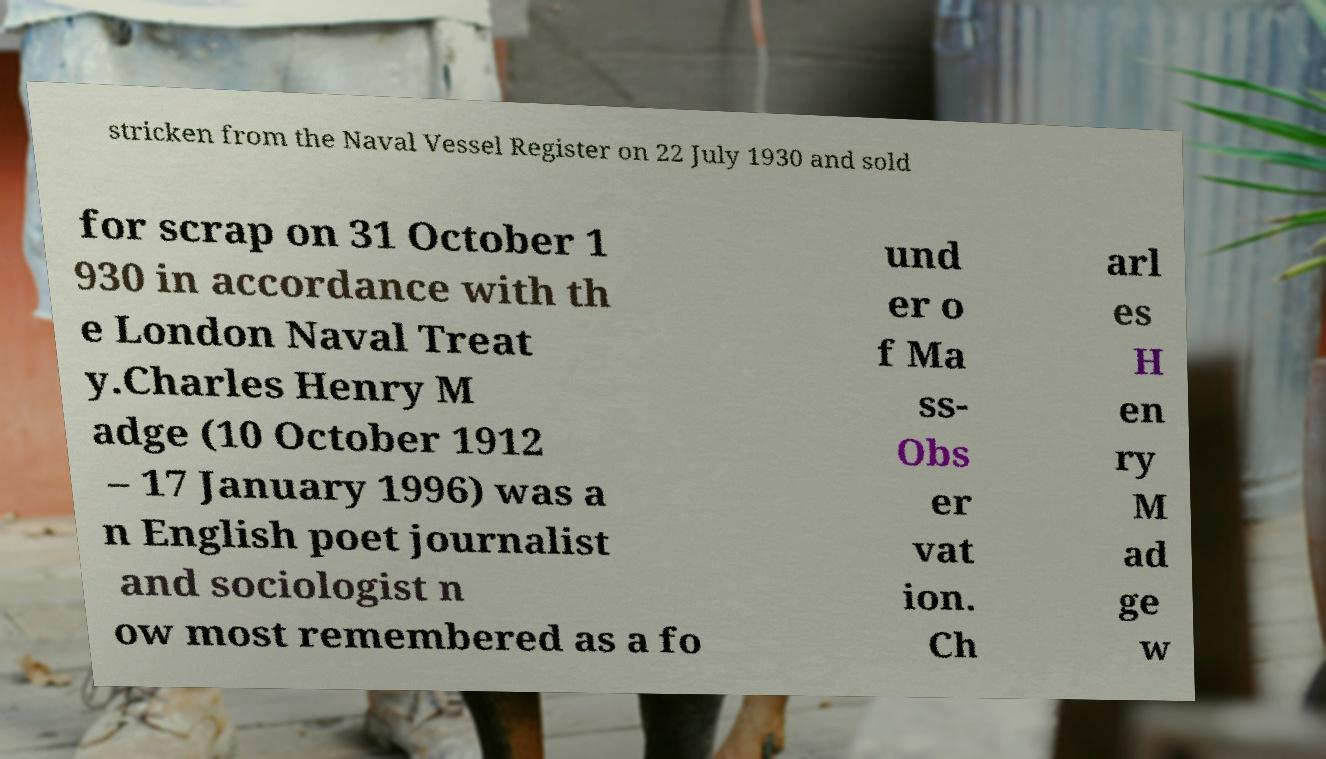Can you read and provide the text displayed in the image?This photo seems to have some interesting text. Can you extract and type it out for me? stricken from the Naval Vessel Register on 22 July 1930 and sold for scrap on 31 October 1 930 in accordance with th e London Naval Treat y.Charles Henry M adge (10 October 1912 – 17 January 1996) was a n English poet journalist and sociologist n ow most remembered as a fo und er o f Ma ss- Obs er vat ion. Ch arl es H en ry M ad ge w 